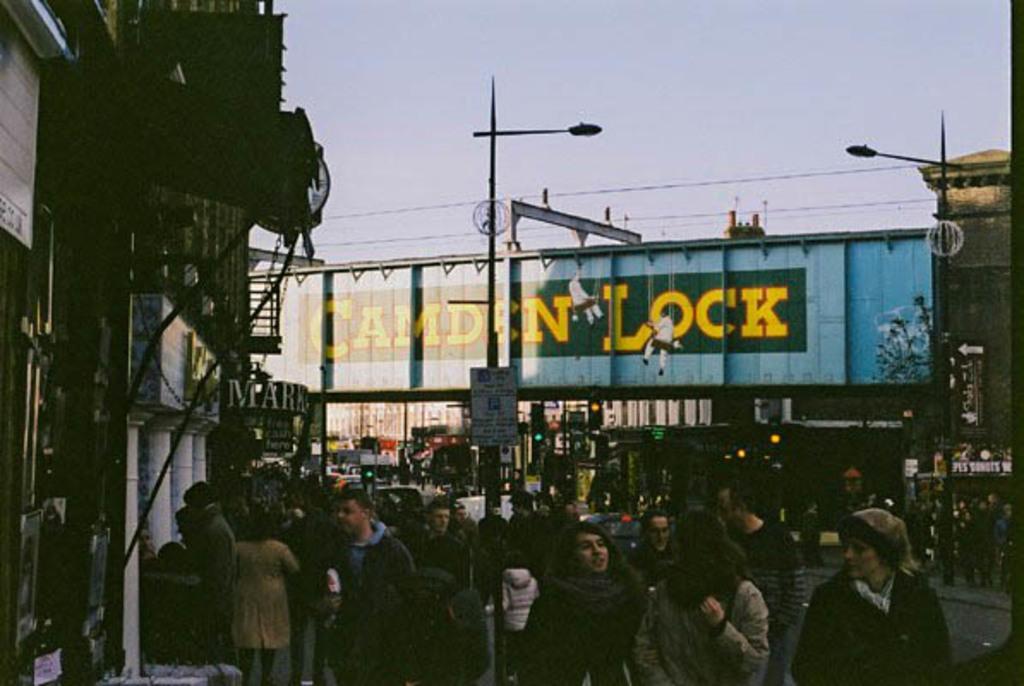Describe this image in one or two sentences. In this image I can see there are people at the down side, in the middle there is an iron board with name Can lock in yellow color. On the left side there are stores, at the top it is the sky. 